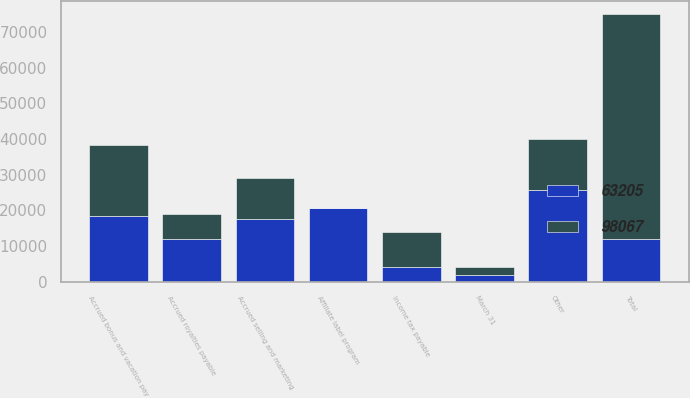Convert chart to OTSL. <chart><loc_0><loc_0><loc_500><loc_500><stacked_bar_chart><ecel><fcel>March 31<fcel>Accrued royalties payable<fcel>Accrued selling and marketing<fcel>Affiliate label program<fcel>Income tax payable<fcel>Accrued bonus and vacation pay<fcel>Other<fcel>Total<nl><fcel>63205<fcel>2005<fcel>11851<fcel>17521<fcel>20605<fcel>3977<fcel>18423<fcel>25690<fcel>11851<nl><fcel>98067<fcel>2004<fcel>7218<fcel>11456<fcel>162<fcel>9897<fcel>20042<fcel>14430<fcel>63205<nl></chart> 